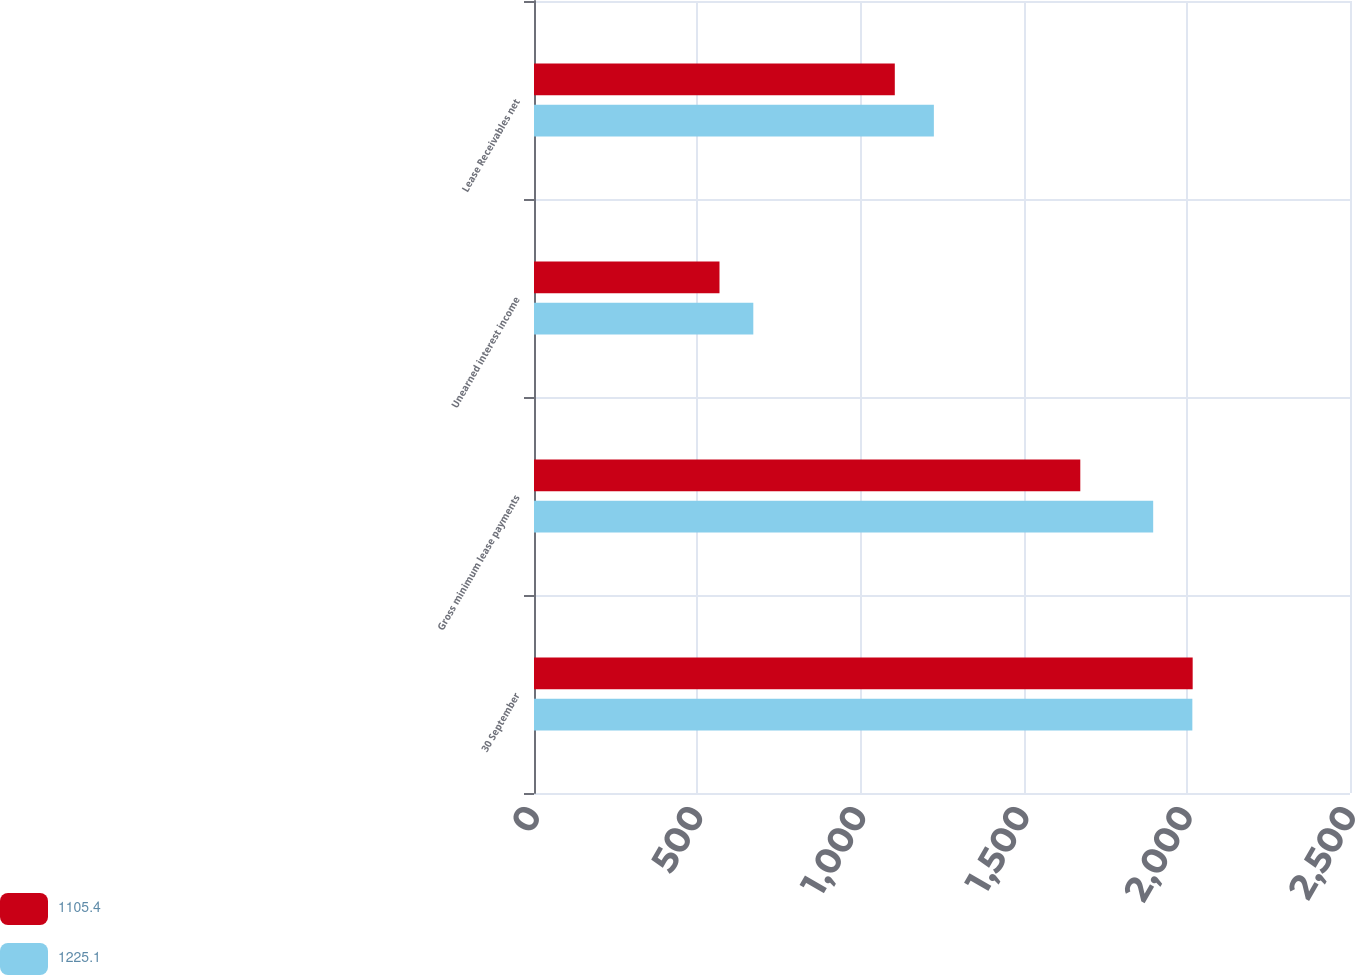<chart> <loc_0><loc_0><loc_500><loc_500><stacked_bar_chart><ecel><fcel>30 September<fcel>Gross minimum lease payments<fcel>Unearned interest income<fcel>Lease Receivables net<nl><fcel>1105.4<fcel>2018<fcel>1673.7<fcel>568.3<fcel>1105.4<nl><fcel>1225.1<fcel>2017<fcel>1897<fcel>671.9<fcel>1225.1<nl></chart> 